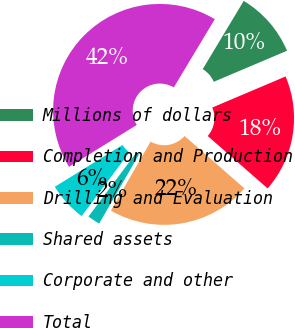Convert chart. <chart><loc_0><loc_0><loc_500><loc_500><pie_chart><fcel>Millions of dollars<fcel>Completion and Production<fcel>Drilling and Evaluation<fcel>Shared assets<fcel>Corporate and other<fcel>Total<nl><fcel>10.01%<fcel>17.82%<fcel>21.88%<fcel>1.91%<fcel>5.96%<fcel>42.42%<nl></chart> 